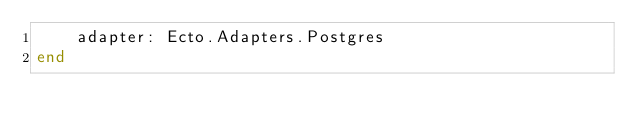<code> <loc_0><loc_0><loc_500><loc_500><_Elixir_>    adapter: Ecto.Adapters.Postgres
end
</code> 